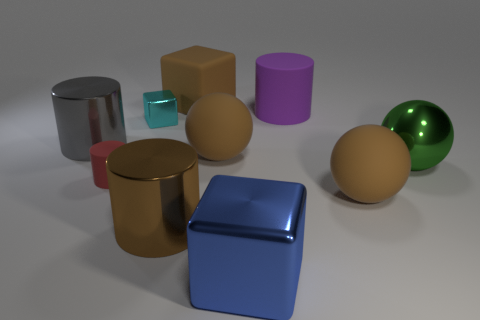The big metal cube has what color?
Your response must be concise. Blue. Is there a big shiny cylinder of the same color as the big rubber cube?
Offer a very short reply. Yes. There is a big sphere that is left of the big blue shiny block; does it have the same color as the matte block?
Give a very brief answer. Yes. What number of objects are either objects that are on the left side of the cyan thing or tiny blocks?
Offer a very short reply. 3. There is a green metal sphere; are there any small cylinders in front of it?
Offer a very short reply. Yes. What is the material of the cylinder that is the same color as the matte cube?
Keep it short and to the point. Metal. Is the material of the brown object that is to the left of the big brown matte cube the same as the green sphere?
Make the answer very short. Yes. There is a big purple rubber cylinder that is on the right side of the metal cylinder left of the small red matte object; is there a matte cylinder that is to the left of it?
Keep it short and to the point. Yes. How many blocks are yellow things or big gray shiny things?
Your answer should be compact. 0. There is a large cube that is behind the large brown metal cylinder; what material is it?
Your answer should be very brief. Rubber. 